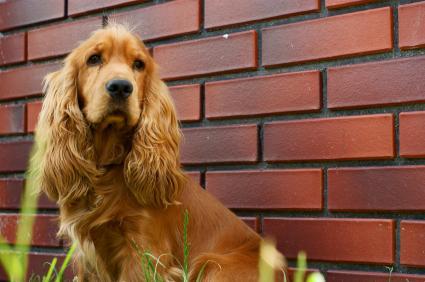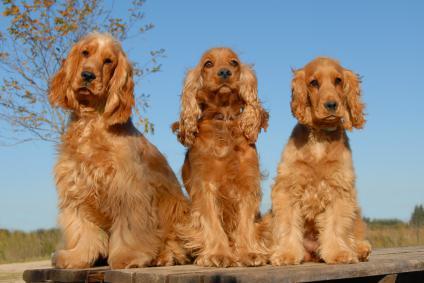The first image is the image on the left, the second image is the image on the right. For the images shown, is this caption "One image shows three dogs sitting in a row." true? Answer yes or no. Yes. 